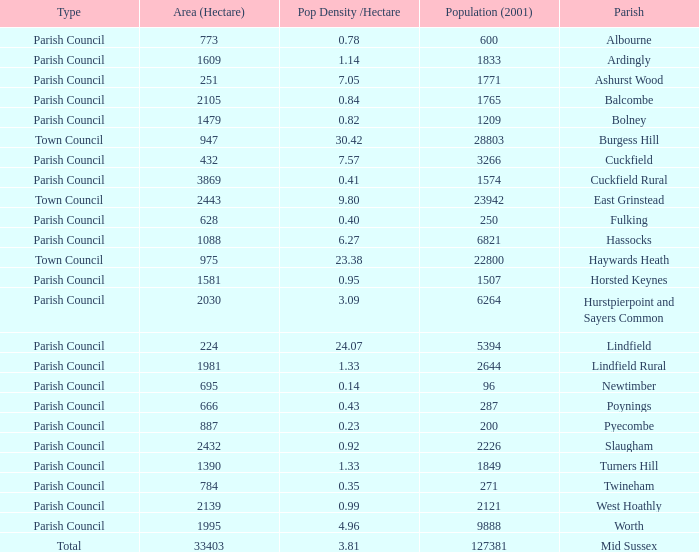What is the area for Worth Parish? 1995.0. 